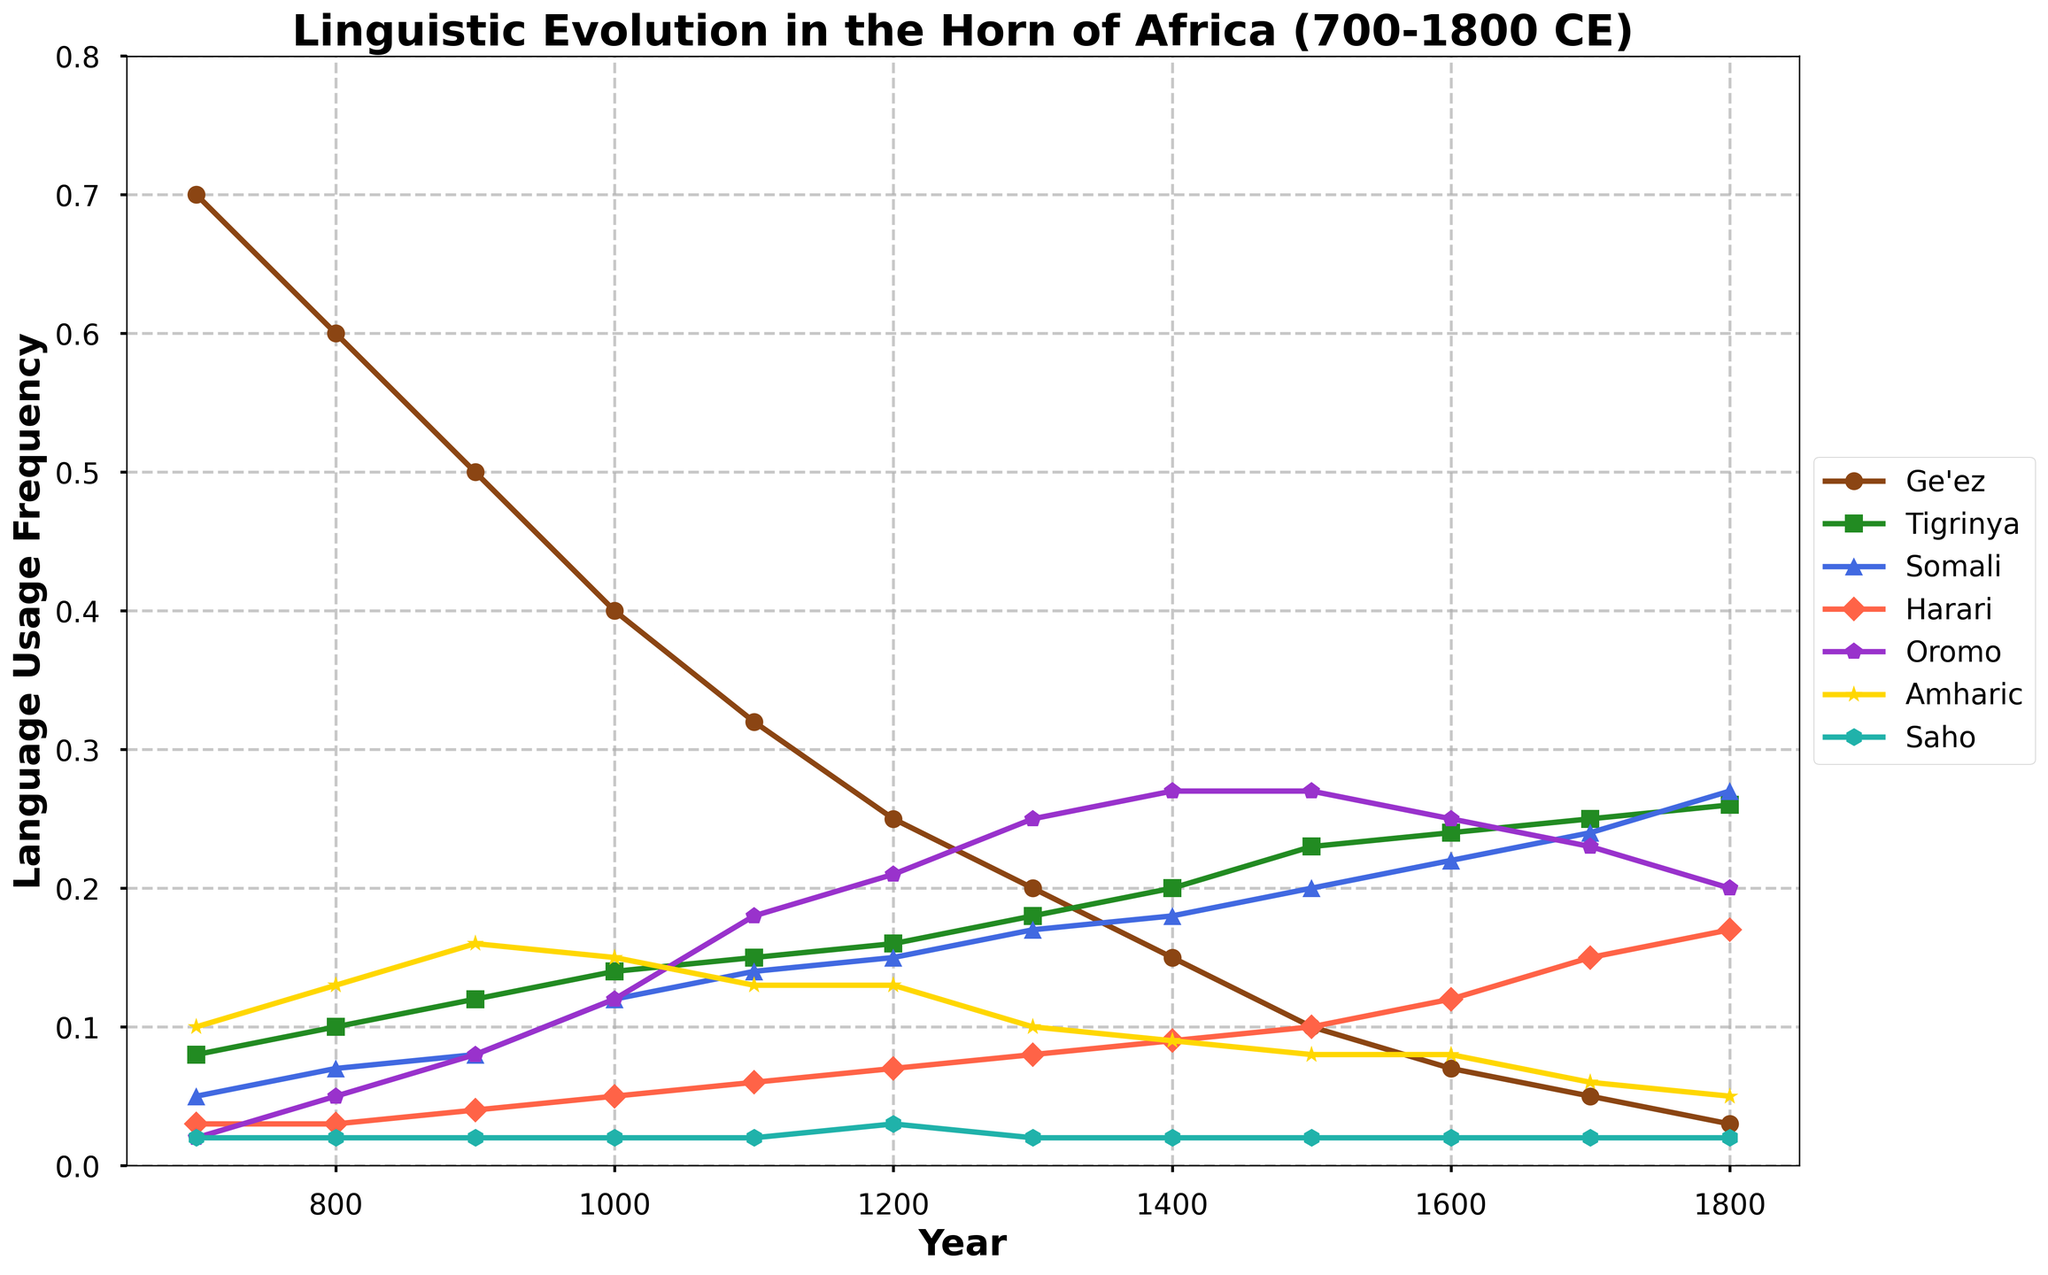What's the title of the figure? The title is usually displayed at the top of the figure. By looking at the top, we can see the title clearly written.
Answer: Linguistic Evolution in the Horn of Africa (700-1800 CE) What is the highest recorded language usage frequency for Ge'ez and in which year? Look for the highest point on the Ge'ez line and see which year it corresponds to on the x-axis.
Answer: 0.70 in 700 Which language shows a steady increase in usage frequency from 700 to 1800? Check for the language whose line steadily rises without drops from 700 to 1800.
Answer: Tigrinya How does the usage frequency of Amharic change between 900 and 1600? Look at the Amharic line between the years 900 and 1600 to observe the trend.
Answer: Decreases from 0.16 to 0.08 Compare the frequency of Somali and Oromo languages in the year 1500. Which is higher and by how much? Look at the values for Somali and Oromo in the year 1500 on the y-axis, then subtract the smaller value from the larger one.
Answer: Oromo is higher by 0.07 (0.27 - 0.20) By what percentage does the usage frequency of Ge'ez decrease from 700 to 1800? Calculate the percentage decrease: (initial - final) / initial * 100. For Ge'ez, (0.70 - 0.03) / 0.70 * 100 = 95.7%.
Answer: 95.7% Between 900 and 1300, which language shows the most significant relative increase in usage frequency? Determine the relative increase for each language by checking the difference in values and identifying the largest.
Answer: Oromo (0.25 - 0.08 = 0.17) Which two languages have the same usage frequencies in the year 700? Look at the values for all languages in the year 700 and identify the ones that match.
Answer: Saho and Oromo (0.02) What trends can you observe in the usage frequency of Tigrinya and Somali from 1500 to 1800? Focus on the section of the time series from 1500 to 1800 for the lines representing Tigrinya and Somali to describe their trends.
Answer: Tigrinya increases while Somali increases and then slightly dips How do the linguistic trends of Harari and Saho compare throughout the period 700 to 1800? Inspect the lines for Harari and Saho across the entire period for any notable similarities or differences in their trends.
Answer: Harari shows a steady increase, whereas Saho remains mostly constant 